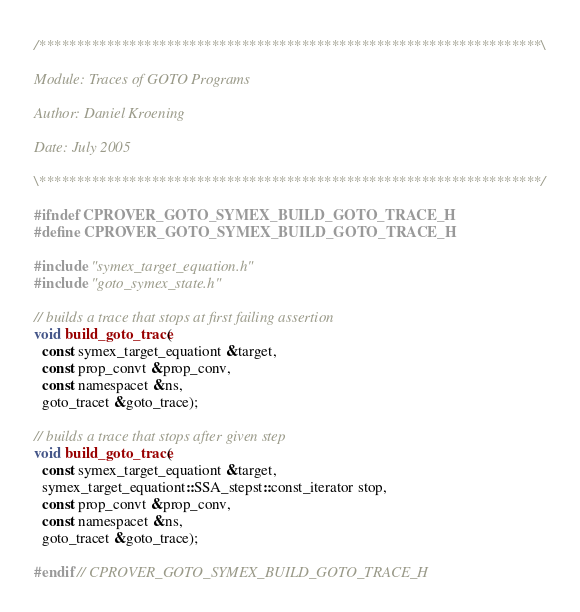Convert code to text. <code><loc_0><loc_0><loc_500><loc_500><_C_>/*******************************************************************\

Module: Traces of GOTO Programs

Author: Daniel Kroening

Date: July 2005

\*******************************************************************/

#ifndef CPROVER_GOTO_SYMEX_BUILD_GOTO_TRACE_H
#define CPROVER_GOTO_SYMEX_BUILD_GOTO_TRACE_H

#include "symex_target_equation.h"
#include "goto_symex_state.h"

// builds a trace that stops at first failing assertion
void build_goto_trace(
  const symex_target_equationt &target,
  const prop_convt &prop_conv,
  const namespacet &ns,
  goto_tracet &goto_trace);

// builds a trace that stops after given step
void build_goto_trace(
  const symex_target_equationt &target,
  symex_target_equationt::SSA_stepst::const_iterator stop,
  const prop_convt &prop_conv,
  const namespacet &ns,
  goto_tracet &goto_trace);

#endif // CPROVER_GOTO_SYMEX_BUILD_GOTO_TRACE_H
</code> 